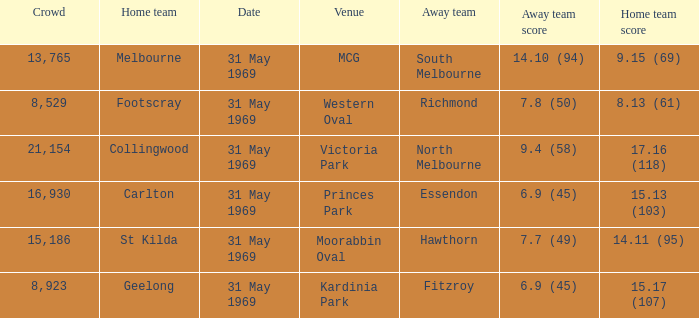What is the record for the most people gathered in victoria park? 21154.0. 